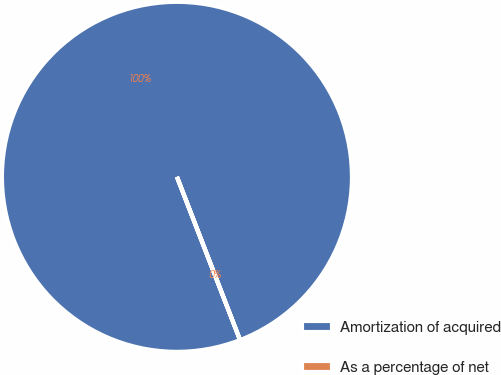Convert chart. <chart><loc_0><loc_0><loc_500><loc_500><pie_chart><fcel>Amortization of acquired<fcel>As a percentage of net<nl><fcel>100.0%<fcel>0.0%<nl></chart> 